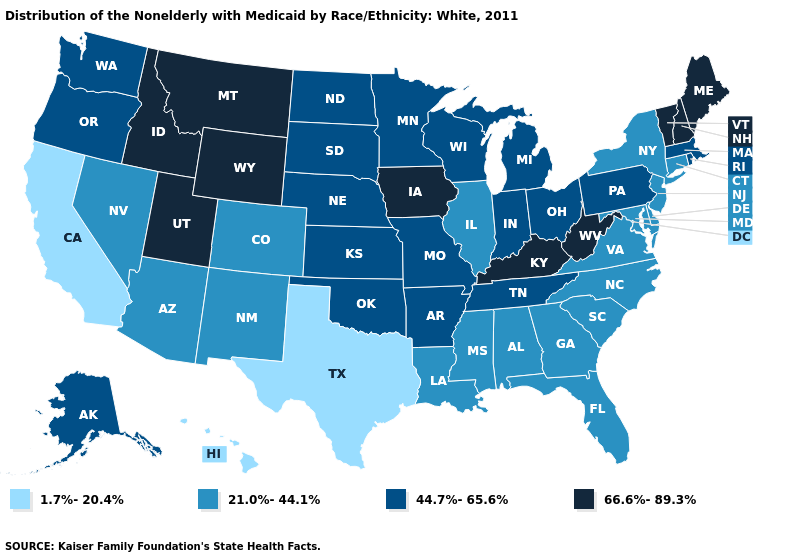Does the first symbol in the legend represent the smallest category?
Answer briefly. Yes. What is the highest value in states that border North Dakota?
Short answer required. 66.6%-89.3%. What is the lowest value in the USA?
Be succinct. 1.7%-20.4%. Name the states that have a value in the range 66.6%-89.3%?
Quick response, please. Idaho, Iowa, Kentucky, Maine, Montana, New Hampshire, Utah, Vermont, West Virginia, Wyoming. What is the highest value in the USA?
Be succinct. 66.6%-89.3%. What is the value of New York?
Quick response, please. 21.0%-44.1%. Among the states that border New Hampshire , does Vermont have the lowest value?
Short answer required. No. Name the states that have a value in the range 21.0%-44.1%?
Be succinct. Alabama, Arizona, Colorado, Connecticut, Delaware, Florida, Georgia, Illinois, Louisiana, Maryland, Mississippi, Nevada, New Jersey, New Mexico, New York, North Carolina, South Carolina, Virginia. Name the states that have a value in the range 1.7%-20.4%?
Answer briefly. California, Hawaii, Texas. Which states have the highest value in the USA?
Concise answer only. Idaho, Iowa, Kentucky, Maine, Montana, New Hampshire, Utah, Vermont, West Virginia, Wyoming. Name the states that have a value in the range 21.0%-44.1%?
Write a very short answer. Alabama, Arizona, Colorado, Connecticut, Delaware, Florida, Georgia, Illinois, Louisiana, Maryland, Mississippi, Nevada, New Jersey, New Mexico, New York, North Carolina, South Carolina, Virginia. How many symbols are there in the legend?
Concise answer only. 4. Name the states that have a value in the range 21.0%-44.1%?
Short answer required. Alabama, Arizona, Colorado, Connecticut, Delaware, Florida, Georgia, Illinois, Louisiana, Maryland, Mississippi, Nevada, New Jersey, New Mexico, New York, North Carolina, South Carolina, Virginia. Name the states that have a value in the range 66.6%-89.3%?
Keep it brief. Idaho, Iowa, Kentucky, Maine, Montana, New Hampshire, Utah, Vermont, West Virginia, Wyoming. Name the states that have a value in the range 1.7%-20.4%?
Keep it brief. California, Hawaii, Texas. 